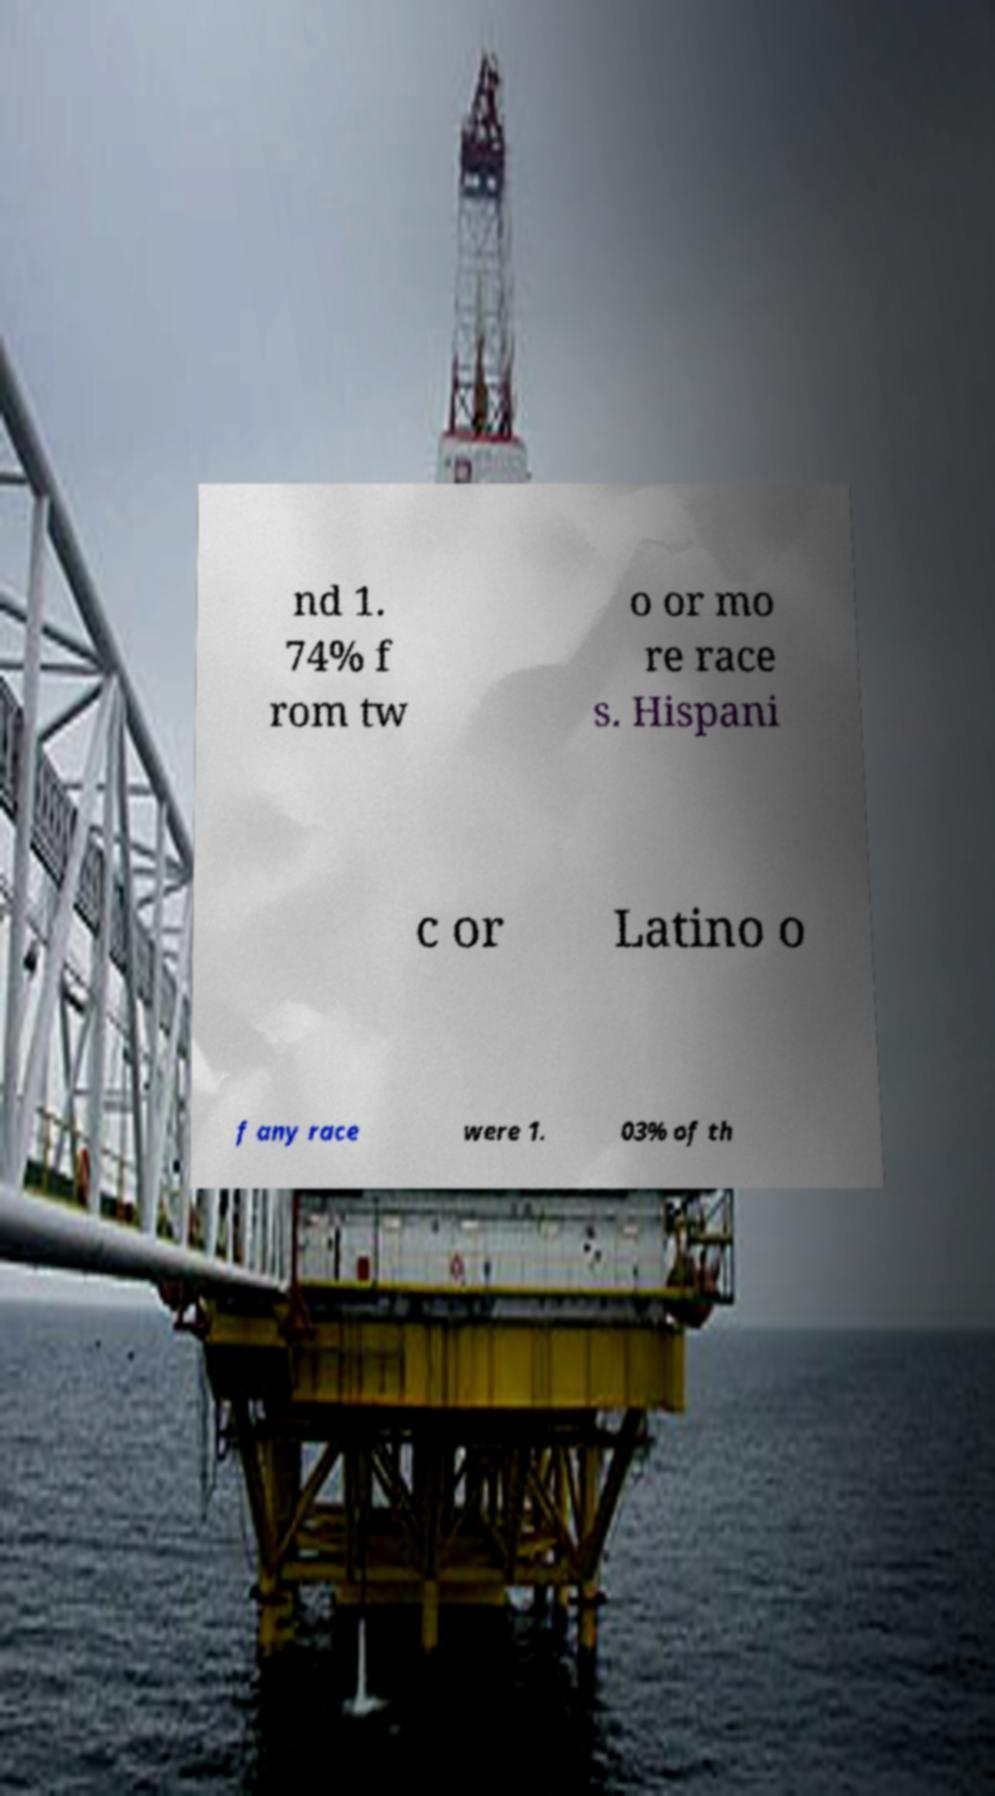Please identify and transcribe the text found in this image. nd 1. 74% f rom tw o or mo re race s. Hispani c or Latino o f any race were 1. 03% of th 